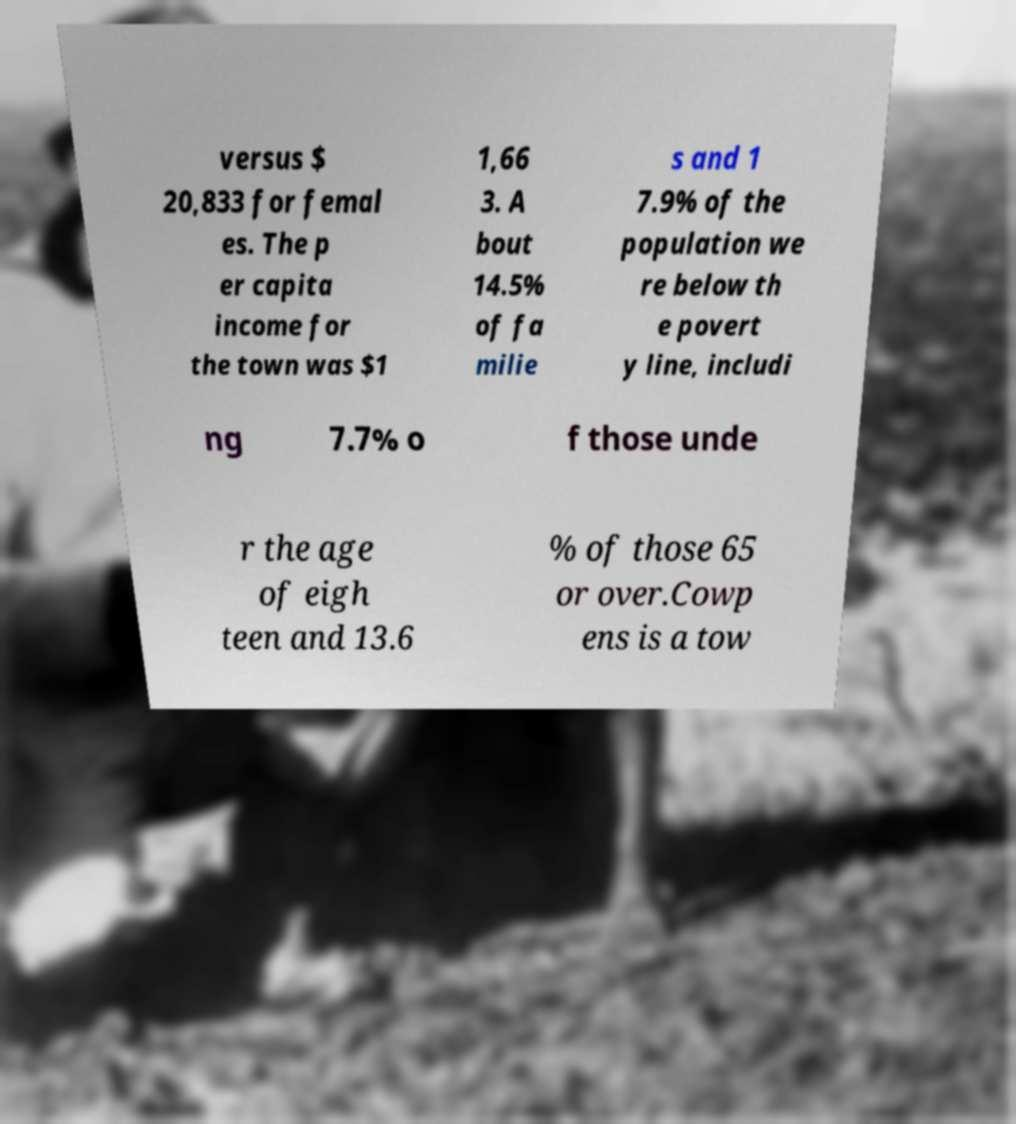I need the written content from this picture converted into text. Can you do that? versus $ 20,833 for femal es. The p er capita income for the town was $1 1,66 3. A bout 14.5% of fa milie s and 1 7.9% of the population we re below th e povert y line, includi ng 7.7% o f those unde r the age of eigh teen and 13.6 % of those 65 or over.Cowp ens is a tow 